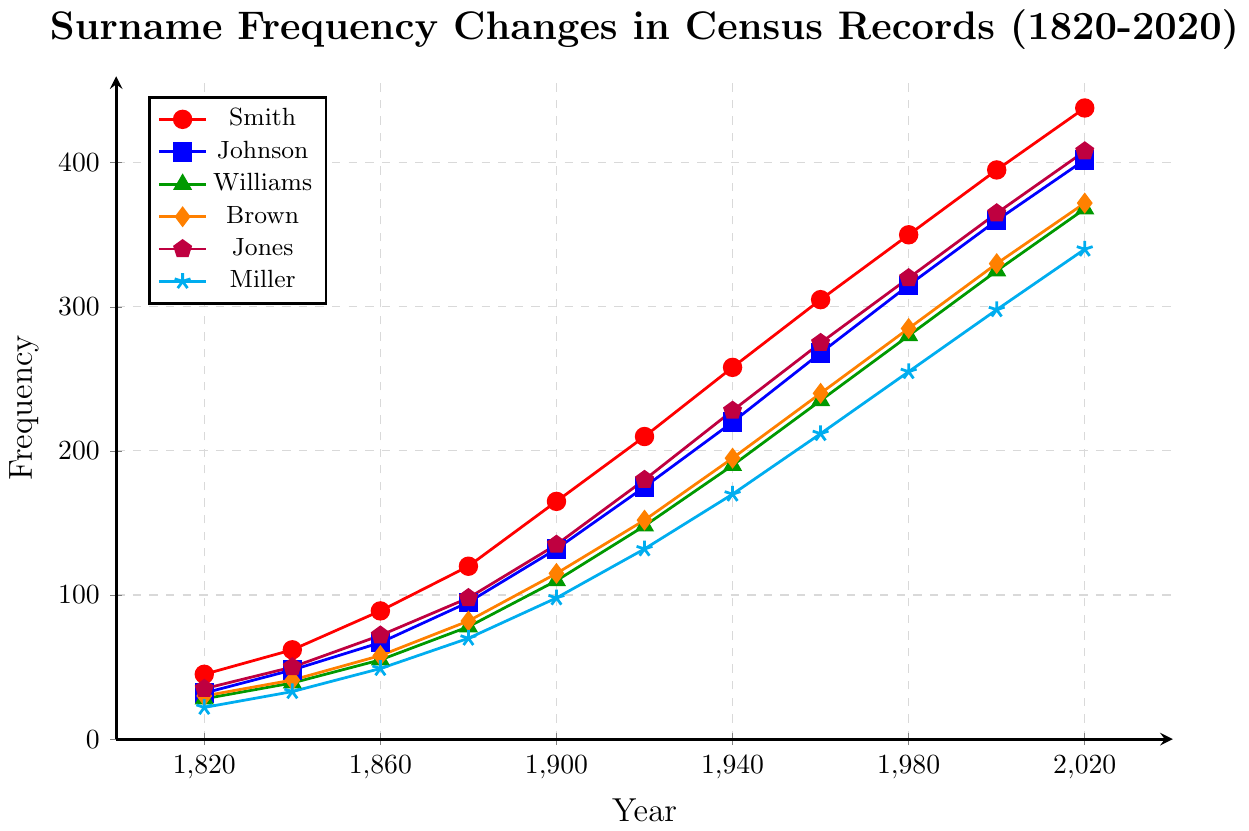When did the surname "Smith" surpass 200 in frequency? Look at the red line representing "Smith" on the plot. Locate the point where its frequency first exceeds 200, which is between the years 1920 and 1940. The exact year when this surpasses 200 is at 1920
Answer: 1920 Which surname had the highest frequency in 1960? Examine the plot at the year 1960 and compare the heights of all the lines. The highest frequency in 1960 is for the surname represented by the purple line, which is "Jones".
Answer: Jones How much did the frequency of "Miller" increase from 1820 to 2020? Identify the starting frequency of "Miller" in 1820, which is 22, and its frequency in 2020, which is 340. Subtract the value of 1820's frequency from 2020's frequency: 340 - 22 = 318.
Answer: 318 What is the difference in frequency between "Johnson" and "Brown" in 2020? Locate the frequencies of "Johnson" (blue line) and "Brown" (orange line) in 2020. Johnson is at 402 and Brown is at 372. Calculate the difference: 402 - 372 = 30.
Answer: 30 In which year did the surname "Williams" have a frequency of approximately 110? Follow the green line representing "Williams" and find the point where it is closest to 110. This occurs around the year 1900.
Answer: 1900 Between which two census years did the surname "Smith" see its largest increase in frequency? Compare adjacent points on the red line for "Smith" and identify the pair of years with the largest vertical increase. The largest increase is between 1900 (165) and 1920 (210), an increase of 45.
Answer: 1900 and 1920 Which surname had the smallest increase in frequency from 1960 to 1980? Calculate the difference in frequencies for all surnames between 1960 and 1980. "Smith" goes from 305 to 350 (+45), "Johnson" from 268 to 315 (+47), "Williams" from 235 to 280 (+45), "Brown" from 240 to 285 (+45), "Jones" from 275 to 320 (+45), and "Miller" from 212 to 255 (+43). The surname "Miller" has the smallest increase of 43.
Answer: Miller 